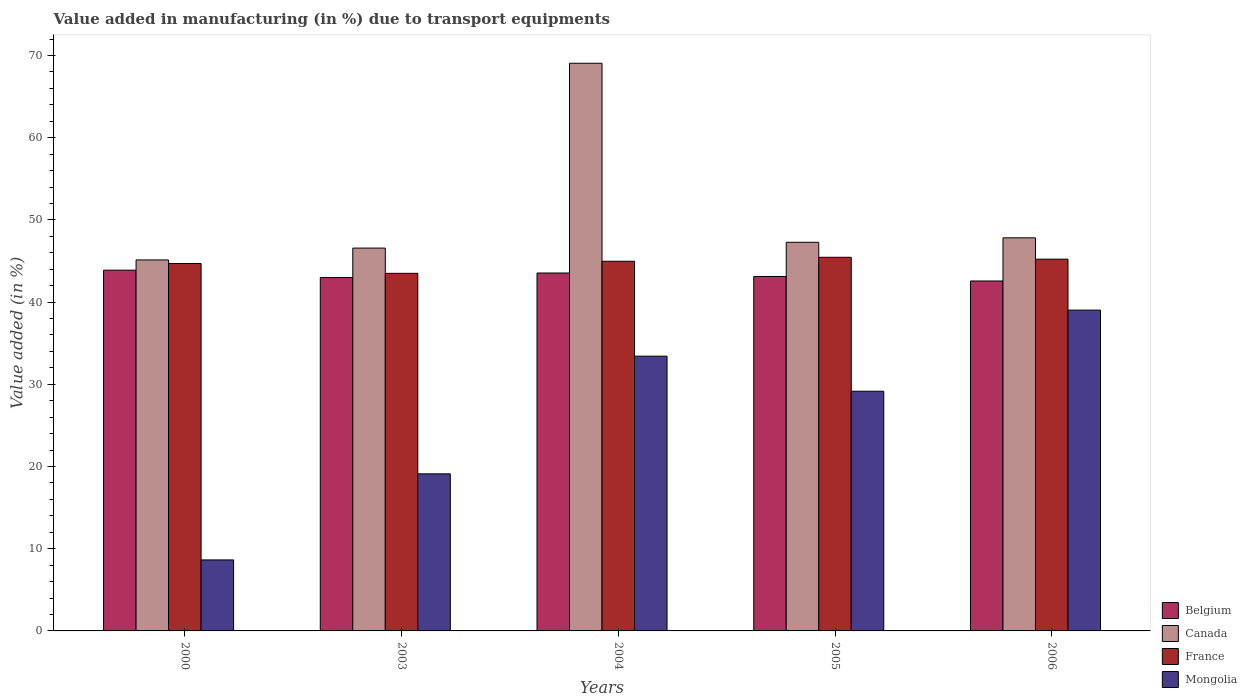How many groups of bars are there?
Your response must be concise. 5. Are the number of bars per tick equal to the number of legend labels?
Keep it short and to the point. Yes. How many bars are there on the 2nd tick from the left?
Give a very brief answer. 4. What is the label of the 3rd group of bars from the left?
Your response must be concise. 2004. What is the percentage of value added in manufacturing due to transport equipments in Belgium in 2006?
Ensure brevity in your answer.  42.57. Across all years, what is the maximum percentage of value added in manufacturing due to transport equipments in France?
Make the answer very short. 45.45. Across all years, what is the minimum percentage of value added in manufacturing due to transport equipments in Canada?
Your answer should be very brief. 45.13. What is the total percentage of value added in manufacturing due to transport equipments in Belgium in the graph?
Your response must be concise. 216.1. What is the difference between the percentage of value added in manufacturing due to transport equipments in Canada in 2000 and that in 2006?
Provide a succinct answer. -2.69. What is the difference between the percentage of value added in manufacturing due to transport equipments in Canada in 2006 and the percentage of value added in manufacturing due to transport equipments in Mongolia in 2004?
Offer a terse response. 14.39. What is the average percentage of value added in manufacturing due to transport equipments in Mongolia per year?
Ensure brevity in your answer.  25.87. In the year 2000, what is the difference between the percentage of value added in manufacturing due to transport equipments in Mongolia and percentage of value added in manufacturing due to transport equipments in France?
Provide a succinct answer. -36.06. In how many years, is the percentage of value added in manufacturing due to transport equipments in France greater than 42 %?
Make the answer very short. 5. What is the ratio of the percentage of value added in manufacturing due to transport equipments in Canada in 2000 to that in 2006?
Give a very brief answer. 0.94. What is the difference between the highest and the second highest percentage of value added in manufacturing due to transport equipments in Mongolia?
Offer a very short reply. 5.6. What is the difference between the highest and the lowest percentage of value added in manufacturing due to transport equipments in Canada?
Ensure brevity in your answer.  23.92. In how many years, is the percentage of value added in manufacturing due to transport equipments in Mongolia greater than the average percentage of value added in manufacturing due to transport equipments in Mongolia taken over all years?
Offer a very short reply. 3. Is it the case that in every year, the sum of the percentage of value added in manufacturing due to transport equipments in Belgium and percentage of value added in manufacturing due to transport equipments in Canada is greater than the sum of percentage of value added in manufacturing due to transport equipments in France and percentage of value added in manufacturing due to transport equipments in Mongolia?
Provide a short and direct response. No. What does the 4th bar from the left in 2000 represents?
Keep it short and to the point. Mongolia. How many bars are there?
Offer a very short reply. 20. How many years are there in the graph?
Your response must be concise. 5. Where does the legend appear in the graph?
Give a very brief answer. Bottom right. How are the legend labels stacked?
Provide a short and direct response. Vertical. What is the title of the graph?
Make the answer very short. Value added in manufacturing (in %) due to transport equipments. Does "San Marino" appear as one of the legend labels in the graph?
Offer a very short reply. No. What is the label or title of the Y-axis?
Your answer should be compact. Value added (in %). What is the Value added (in %) in Belgium in 2000?
Your answer should be very brief. 43.88. What is the Value added (in %) of Canada in 2000?
Provide a succinct answer. 45.13. What is the Value added (in %) in France in 2000?
Your response must be concise. 44.7. What is the Value added (in %) in Mongolia in 2000?
Offer a terse response. 8.64. What is the Value added (in %) of Belgium in 2003?
Ensure brevity in your answer.  42.99. What is the Value added (in %) in Canada in 2003?
Ensure brevity in your answer.  46.57. What is the Value added (in %) of France in 2003?
Keep it short and to the point. 43.5. What is the Value added (in %) in Mongolia in 2003?
Provide a succinct answer. 19.11. What is the Value added (in %) in Belgium in 2004?
Provide a short and direct response. 43.54. What is the Value added (in %) of Canada in 2004?
Keep it short and to the point. 69.05. What is the Value added (in %) in France in 2004?
Your answer should be compact. 44.97. What is the Value added (in %) in Mongolia in 2004?
Offer a very short reply. 33.42. What is the Value added (in %) in Belgium in 2005?
Ensure brevity in your answer.  43.12. What is the Value added (in %) in Canada in 2005?
Your response must be concise. 47.28. What is the Value added (in %) of France in 2005?
Keep it short and to the point. 45.45. What is the Value added (in %) of Mongolia in 2005?
Your response must be concise. 29.16. What is the Value added (in %) of Belgium in 2006?
Provide a succinct answer. 42.57. What is the Value added (in %) of Canada in 2006?
Your response must be concise. 47.82. What is the Value added (in %) in France in 2006?
Make the answer very short. 45.22. What is the Value added (in %) of Mongolia in 2006?
Keep it short and to the point. 39.03. Across all years, what is the maximum Value added (in %) in Belgium?
Make the answer very short. 43.88. Across all years, what is the maximum Value added (in %) in Canada?
Make the answer very short. 69.05. Across all years, what is the maximum Value added (in %) of France?
Provide a succinct answer. 45.45. Across all years, what is the maximum Value added (in %) of Mongolia?
Keep it short and to the point. 39.03. Across all years, what is the minimum Value added (in %) of Belgium?
Provide a succinct answer. 42.57. Across all years, what is the minimum Value added (in %) in Canada?
Provide a short and direct response. 45.13. Across all years, what is the minimum Value added (in %) in France?
Offer a very short reply. 43.5. Across all years, what is the minimum Value added (in %) in Mongolia?
Provide a succinct answer. 8.64. What is the total Value added (in %) in Belgium in the graph?
Offer a very short reply. 216.1. What is the total Value added (in %) in Canada in the graph?
Give a very brief answer. 255.85. What is the total Value added (in %) in France in the graph?
Ensure brevity in your answer.  223.84. What is the total Value added (in %) of Mongolia in the graph?
Provide a succinct answer. 129.35. What is the difference between the Value added (in %) of Belgium in 2000 and that in 2003?
Your answer should be very brief. 0.9. What is the difference between the Value added (in %) of Canada in 2000 and that in 2003?
Make the answer very short. -1.44. What is the difference between the Value added (in %) of France in 2000 and that in 2003?
Your answer should be very brief. 1.2. What is the difference between the Value added (in %) of Mongolia in 2000 and that in 2003?
Provide a succinct answer. -10.47. What is the difference between the Value added (in %) in Belgium in 2000 and that in 2004?
Your answer should be very brief. 0.35. What is the difference between the Value added (in %) of Canada in 2000 and that in 2004?
Your response must be concise. -23.92. What is the difference between the Value added (in %) in France in 2000 and that in 2004?
Make the answer very short. -0.27. What is the difference between the Value added (in %) in Mongolia in 2000 and that in 2004?
Offer a very short reply. -24.79. What is the difference between the Value added (in %) in Belgium in 2000 and that in 2005?
Offer a terse response. 0.77. What is the difference between the Value added (in %) of Canada in 2000 and that in 2005?
Provide a short and direct response. -2.15. What is the difference between the Value added (in %) of France in 2000 and that in 2005?
Your answer should be compact. -0.75. What is the difference between the Value added (in %) of Mongolia in 2000 and that in 2005?
Make the answer very short. -20.52. What is the difference between the Value added (in %) of Belgium in 2000 and that in 2006?
Make the answer very short. 1.32. What is the difference between the Value added (in %) in Canada in 2000 and that in 2006?
Keep it short and to the point. -2.69. What is the difference between the Value added (in %) in France in 2000 and that in 2006?
Give a very brief answer. -0.53. What is the difference between the Value added (in %) in Mongolia in 2000 and that in 2006?
Offer a terse response. -30.39. What is the difference between the Value added (in %) in Belgium in 2003 and that in 2004?
Ensure brevity in your answer.  -0.55. What is the difference between the Value added (in %) in Canada in 2003 and that in 2004?
Make the answer very short. -22.48. What is the difference between the Value added (in %) of France in 2003 and that in 2004?
Keep it short and to the point. -1.47. What is the difference between the Value added (in %) of Mongolia in 2003 and that in 2004?
Your answer should be compact. -14.32. What is the difference between the Value added (in %) of Belgium in 2003 and that in 2005?
Give a very brief answer. -0.13. What is the difference between the Value added (in %) in Canada in 2003 and that in 2005?
Offer a very short reply. -0.71. What is the difference between the Value added (in %) of France in 2003 and that in 2005?
Offer a very short reply. -1.95. What is the difference between the Value added (in %) of Mongolia in 2003 and that in 2005?
Offer a terse response. -10.05. What is the difference between the Value added (in %) in Belgium in 2003 and that in 2006?
Your answer should be compact. 0.42. What is the difference between the Value added (in %) in Canada in 2003 and that in 2006?
Your response must be concise. -1.25. What is the difference between the Value added (in %) in France in 2003 and that in 2006?
Your response must be concise. -1.72. What is the difference between the Value added (in %) in Mongolia in 2003 and that in 2006?
Provide a succinct answer. -19.92. What is the difference between the Value added (in %) in Belgium in 2004 and that in 2005?
Provide a succinct answer. 0.42. What is the difference between the Value added (in %) in Canada in 2004 and that in 2005?
Your answer should be compact. 21.78. What is the difference between the Value added (in %) of France in 2004 and that in 2005?
Make the answer very short. -0.48. What is the difference between the Value added (in %) in Mongolia in 2004 and that in 2005?
Make the answer very short. 4.27. What is the difference between the Value added (in %) of Canada in 2004 and that in 2006?
Make the answer very short. 21.24. What is the difference between the Value added (in %) of France in 2004 and that in 2006?
Your response must be concise. -0.25. What is the difference between the Value added (in %) of Mongolia in 2004 and that in 2006?
Your response must be concise. -5.6. What is the difference between the Value added (in %) of Belgium in 2005 and that in 2006?
Your answer should be compact. 0.55. What is the difference between the Value added (in %) in Canada in 2005 and that in 2006?
Your response must be concise. -0.54. What is the difference between the Value added (in %) of France in 2005 and that in 2006?
Your answer should be very brief. 0.23. What is the difference between the Value added (in %) in Mongolia in 2005 and that in 2006?
Ensure brevity in your answer.  -9.87. What is the difference between the Value added (in %) in Belgium in 2000 and the Value added (in %) in Canada in 2003?
Offer a very short reply. -2.69. What is the difference between the Value added (in %) of Belgium in 2000 and the Value added (in %) of France in 2003?
Your response must be concise. 0.39. What is the difference between the Value added (in %) in Belgium in 2000 and the Value added (in %) in Mongolia in 2003?
Your answer should be compact. 24.78. What is the difference between the Value added (in %) of Canada in 2000 and the Value added (in %) of France in 2003?
Provide a succinct answer. 1.63. What is the difference between the Value added (in %) of Canada in 2000 and the Value added (in %) of Mongolia in 2003?
Provide a short and direct response. 26.02. What is the difference between the Value added (in %) in France in 2000 and the Value added (in %) in Mongolia in 2003?
Your response must be concise. 25.59. What is the difference between the Value added (in %) of Belgium in 2000 and the Value added (in %) of Canada in 2004?
Offer a terse response. -25.17. What is the difference between the Value added (in %) of Belgium in 2000 and the Value added (in %) of France in 2004?
Offer a terse response. -1.08. What is the difference between the Value added (in %) in Belgium in 2000 and the Value added (in %) in Mongolia in 2004?
Offer a terse response. 10.46. What is the difference between the Value added (in %) of Canada in 2000 and the Value added (in %) of France in 2004?
Ensure brevity in your answer.  0.16. What is the difference between the Value added (in %) in Canada in 2000 and the Value added (in %) in Mongolia in 2004?
Your answer should be very brief. 11.71. What is the difference between the Value added (in %) in France in 2000 and the Value added (in %) in Mongolia in 2004?
Your answer should be very brief. 11.27. What is the difference between the Value added (in %) in Belgium in 2000 and the Value added (in %) in Canada in 2005?
Give a very brief answer. -3.39. What is the difference between the Value added (in %) of Belgium in 2000 and the Value added (in %) of France in 2005?
Make the answer very short. -1.57. What is the difference between the Value added (in %) in Belgium in 2000 and the Value added (in %) in Mongolia in 2005?
Provide a short and direct response. 14.73. What is the difference between the Value added (in %) in Canada in 2000 and the Value added (in %) in France in 2005?
Ensure brevity in your answer.  -0.32. What is the difference between the Value added (in %) of Canada in 2000 and the Value added (in %) of Mongolia in 2005?
Your answer should be compact. 15.97. What is the difference between the Value added (in %) of France in 2000 and the Value added (in %) of Mongolia in 2005?
Your response must be concise. 15.54. What is the difference between the Value added (in %) in Belgium in 2000 and the Value added (in %) in Canada in 2006?
Offer a terse response. -3.93. What is the difference between the Value added (in %) in Belgium in 2000 and the Value added (in %) in France in 2006?
Ensure brevity in your answer.  -1.34. What is the difference between the Value added (in %) of Belgium in 2000 and the Value added (in %) of Mongolia in 2006?
Offer a terse response. 4.86. What is the difference between the Value added (in %) in Canada in 2000 and the Value added (in %) in France in 2006?
Offer a terse response. -0.09. What is the difference between the Value added (in %) of Canada in 2000 and the Value added (in %) of Mongolia in 2006?
Make the answer very short. 6.1. What is the difference between the Value added (in %) of France in 2000 and the Value added (in %) of Mongolia in 2006?
Your response must be concise. 5.67. What is the difference between the Value added (in %) in Belgium in 2003 and the Value added (in %) in Canada in 2004?
Keep it short and to the point. -26.07. What is the difference between the Value added (in %) of Belgium in 2003 and the Value added (in %) of France in 2004?
Offer a terse response. -1.98. What is the difference between the Value added (in %) of Belgium in 2003 and the Value added (in %) of Mongolia in 2004?
Your response must be concise. 9.56. What is the difference between the Value added (in %) in Canada in 2003 and the Value added (in %) in France in 2004?
Provide a short and direct response. 1.6. What is the difference between the Value added (in %) of Canada in 2003 and the Value added (in %) of Mongolia in 2004?
Offer a terse response. 13.15. What is the difference between the Value added (in %) of France in 2003 and the Value added (in %) of Mongolia in 2004?
Keep it short and to the point. 10.07. What is the difference between the Value added (in %) in Belgium in 2003 and the Value added (in %) in Canada in 2005?
Your answer should be compact. -4.29. What is the difference between the Value added (in %) of Belgium in 2003 and the Value added (in %) of France in 2005?
Provide a succinct answer. -2.46. What is the difference between the Value added (in %) in Belgium in 2003 and the Value added (in %) in Mongolia in 2005?
Make the answer very short. 13.83. What is the difference between the Value added (in %) in Canada in 2003 and the Value added (in %) in France in 2005?
Give a very brief answer. 1.12. What is the difference between the Value added (in %) in Canada in 2003 and the Value added (in %) in Mongolia in 2005?
Provide a short and direct response. 17.41. What is the difference between the Value added (in %) in France in 2003 and the Value added (in %) in Mongolia in 2005?
Provide a succinct answer. 14.34. What is the difference between the Value added (in %) of Belgium in 2003 and the Value added (in %) of Canada in 2006?
Your response must be concise. -4.83. What is the difference between the Value added (in %) of Belgium in 2003 and the Value added (in %) of France in 2006?
Provide a succinct answer. -2.24. What is the difference between the Value added (in %) in Belgium in 2003 and the Value added (in %) in Mongolia in 2006?
Offer a terse response. 3.96. What is the difference between the Value added (in %) of Canada in 2003 and the Value added (in %) of France in 2006?
Keep it short and to the point. 1.35. What is the difference between the Value added (in %) of Canada in 2003 and the Value added (in %) of Mongolia in 2006?
Your response must be concise. 7.54. What is the difference between the Value added (in %) in France in 2003 and the Value added (in %) in Mongolia in 2006?
Your answer should be very brief. 4.47. What is the difference between the Value added (in %) of Belgium in 2004 and the Value added (in %) of Canada in 2005?
Your response must be concise. -3.74. What is the difference between the Value added (in %) in Belgium in 2004 and the Value added (in %) in France in 2005?
Your response must be concise. -1.91. What is the difference between the Value added (in %) in Belgium in 2004 and the Value added (in %) in Mongolia in 2005?
Provide a succinct answer. 14.38. What is the difference between the Value added (in %) of Canada in 2004 and the Value added (in %) of France in 2005?
Provide a short and direct response. 23.6. What is the difference between the Value added (in %) in Canada in 2004 and the Value added (in %) in Mongolia in 2005?
Your response must be concise. 39.9. What is the difference between the Value added (in %) in France in 2004 and the Value added (in %) in Mongolia in 2005?
Offer a terse response. 15.81. What is the difference between the Value added (in %) in Belgium in 2004 and the Value added (in %) in Canada in 2006?
Offer a very short reply. -4.28. What is the difference between the Value added (in %) of Belgium in 2004 and the Value added (in %) of France in 2006?
Provide a short and direct response. -1.68. What is the difference between the Value added (in %) in Belgium in 2004 and the Value added (in %) in Mongolia in 2006?
Give a very brief answer. 4.51. What is the difference between the Value added (in %) in Canada in 2004 and the Value added (in %) in France in 2006?
Provide a short and direct response. 23.83. What is the difference between the Value added (in %) of Canada in 2004 and the Value added (in %) of Mongolia in 2006?
Provide a short and direct response. 30.03. What is the difference between the Value added (in %) in France in 2004 and the Value added (in %) in Mongolia in 2006?
Provide a short and direct response. 5.94. What is the difference between the Value added (in %) of Belgium in 2005 and the Value added (in %) of Canada in 2006?
Provide a short and direct response. -4.7. What is the difference between the Value added (in %) in Belgium in 2005 and the Value added (in %) in France in 2006?
Keep it short and to the point. -2.11. What is the difference between the Value added (in %) of Belgium in 2005 and the Value added (in %) of Mongolia in 2006?
Provide a short and direct response. 4.09. What is the difference between the Value added (in %) of Canada in 2005 and the Value added (in %) of France in 2006?
Your answer should be compact. 2.05. What is the difference between the Value added (in %) in Canada in 2005 and the Value added (in %) in Mongolia in 2006?
Provide a short and direct response. 8.25. What is the difference between the Value added (in %) in France in 2005 and the Value added (in %) in Mongolia in 2006?
Give a very brief answer. 6.42. What is the average Value added (in %) in Belgium per year?
Provide a succinct answer. 43.22. What is the average Value added (in %) of Canada per year?
Give a very brief answer. 51.17. What is the average Value added (in %) of France per year?
Your response must be concise. 44.77. What is the average Value added (in %) in Mongolia per year?
Provide a succinct answer. 25.87. In the year 2000, what is the difference between the Value added (in %) in Belgium and Value added (in %) in Canada?
Your response must be concise. -1.25. In the year 2000, what is the difference between the Value added (in %) in Belgium and Value added (in %) in France?
Offer a very short reply. -0.81. In the year 2000, what is the difference between the Value added (in %) in Belgium and Value added (in %) in Mongolia?
Offer a terse response. 35.25. In the year 2000, what is the difference between the Value added (in %) of Canada and Value added (in %) of France?
Keep it short and to the point. 0.43. In the year 2000, what is the difference between the Value added (in %) of Canada and Value added (in %) of Mongolia?
Offer a very short reply. 36.49. In the year 2000, what is the difference between the Value added (in %) of France and Value added (in %) of Mongolia?
Offer a very short reply. 36.06. In the year 2003, what is the difference between the Value added (in %) in Belgium and Value added (in %) in Canada?
Give a very brief answer. -3.58. In the year 2003, what is the difference between the Value added (in %) of Belgium and Value added (in %) of France?
Keep it short and to the point. -0.51. In the year 2003, what is the difference between the Value added (in %) of Belgium and Value added (in %) of Mongolia?
Keep it short and to the point. 23.88. In the year 2003, what is the difference between the Value added (in %) of Canada and Value added (in %) of France?
Your answer should be very brief. 3.07. In the year 2003, what is the difference between the Value added (in %) in Canada and Value added (in %) in Mongolia?
Give a very brief answer. 27.46. In the year 2003, what is the difference between the Value added (in %) in France and Value added (in %) in Mongolia?
Make the answer very short. 24.39. In the year 2004, what is the difference between the Value added (in %) of Belgium and Value added (in %) of Canada?
Ensure brevity in your answer.  -25.51. In the year 2004, what is the difference between the Value added (in %) in Belgium and Value added (in %) in France?
Offer a terse response. -1.43. In the year 2004, what is the difference between the Value added (in %) of Belgium and Value added (in %) of Mongolia?
Give a very brief answer. 10.12. In the year 2004, what is the difference between the Value added (in %) of Canada and Value added (in %) of France?
Your answer should be compact. 24.09. In the year 2004, what is the difference between the Value added (in %) of Canada and Value added (in %) of Mongolia?
Give a very brief answer. 35.63. In the year 2004, what is the difference between the Value added (in %) in France and Value added (in %) in Mongolia?
Your response must be concise. 11.54. In the year 2005, what is the difference between the Value added (in %) in Belgium and Value added (in %) in Canada?
Provide a succinct answer. -4.16. In the year 2005, what is the difference between the Value added (in %) in Belgium and Value added (in %) in France?
Provide a succinct answer. -2.33. In the year 2005, what is the difference between the Value added (in %) of Belgium and Value added (in %) of Mongolia?
Provide a short and direct response. 13.96. In the year 2005, what is the difference between the Value added (in %) of Canada and Value added (in %) of France?
Provide a short and direct response. 1.83. In the year 2005, what is the difference between the Value added (in %) in Canada and Value added (in %) in Mongolia?
Ensure brevity in your answer.  18.12. In the year 2005, what is the difference between the Value added (in %) of France and Value added (in %) of Mongolia?
Keep it short and to the point. 16.29. In the year 2006, what is the difference between the Value added (in %) of Belgium and Value added (in %) of Canada?
Your response must be concise. -5.25. In the year 2006, what is the difference between the Value added (in %) of Belgium and Value added (in %) of France?
Your response must be concise. -2.66. In the year 2006, what is the difference between the Value added (in %) of Belgium and Value added (in %) of Mongolia?
Your answer should be very brief. 3.54. In the year 2006, what is the difference between the Value added (in %) in Canada and Value added (in %) in France?
Offer a very short reply. 2.59. In the year 2006, what is the difference between the Value added (in %) of Canada and Value added (in %) of Mongolia?
Provide a short and direct response. 8.79. In the year 2006, what is the difference between the Value added (in %) of France and Value added (in %) of Mongolia?
Your response must be concise. 6.2. What is the ratio of the Value added (in %) in Belgium in 2000 to that in 2003?
Your answer should be very brief. 1.02. What is the ratio of the Value added (in %) in Canada in 2000 to that in 2003?
Provide a short and direct response. 0.97. What is the ratio of the Value added (in %) in France in 2000 to that in 2003?
Ensure brevity in your answer.  1.03. What is the ratio of the Value added (in %) of Mongolia in 2000 to that in 2003?
Your response must be concise. 0.45. What is the ratio of the Value added (in %) of Belgium in 2000 to that in 2004?
Offer a terse response. 1.01. What is the ratio of the Value added (in %) in Canada in 2000 to that in 2004?
Offer a terse response. 0.65. What is the ratio of the Value added (in %) in France in 2000 to that in 2004?
Offer a terse response. 0.99. What is the ratio of the Value added (in %) in Mongolia in 2000 to that in 2004?
Make the answer very short. 0.26. What is the ratio of the Value added (in %) in Belgium in 2000 to that in 2005?
Give a very brief answer. 1.02. What is the ratio of the Value added (in %) in Canada in 2000 to that in 2005?
Your answer should be compact. 0.95. What is the ratio of the Value added (in %) in France in 2000 to that in 2005?
Offer a terse response. 0.98. What is the ratio of the Value added (in %) of Mongolia in 2000 to that in 2005?
Your response must be concise. 0.3. What is the ratio of the Value added (in %) of Belgium in 2000 to that in 2006?
Your response must be concise. 1.03. What is the ratio of the Value added (in %) of Canada in 2000 to that in 2006?
Ensure brevity in your answer.  0.94. What is the ratio of the Value added (in %) in France in 2000 to that in 2006?
Give a very brief answer. 0.99. What is the ratio of the Value added (in %) of Mongolia in 2000 to that in 2006?
Ensure brevity in your answer.  0.22. What is the ratio of the Value added (in %) of Belgium in 2003 to that in 2004?
Keep it short and to the point. 0.99. What is the ratio of the Value added (in %) of Canada in 2003 to that in 2004?
Make the answer very short. 0.67. What is the ratio of the Value added (in %) in France in 2003 to that in 2004?
Your response must be concise. 0.97. What is the ratio of the Value added (in %) in Mongolia in 2003 to that in 2004?
Keep it short and to the point. 0.57. What is the ratio of the Value added (in %) in Belgium in 2003 to that in 2005?
Keep it short and to the point. 1. What is the ratio of the Value added (in %) of Canada in 2003 to that in 2005?
Your response must be concise. 0.99. What is the ratio of the Value added (in %) of France in 2003 to that in 2005?
Make the answer very short. 0.96. What is the ratio of the Value added (in %) in Mongolia in 2003 to that in 2005?
Make the answer very short. 0.66. What is the ratio of the Value added (in %) in Belgium in 2003 to that in 2006?
Keep it short and to the point. 1.01. What is the ratio of the Value added (in %) of Canada in 2003 to that in 2006?
Provide a succinct answer. 0.97. What is the ratio of the Value added (in %) of France in 2003 to that in 2006?
Offer a very short reply. 0.96. What is the ratio of the Value added (in %) of Mongolia in 2003 to that in 2006?
Ensure brevity in your answer.  0.49. What is the ratio of the Value added (in %) of Belgium in 2004 to that in 2005?
Offer a very short reply. 1.01. What is the ratio of the Value added (in %) in Canada in 2004 to that in 2005?
Keep it short and to the point. 1.46. What is the ratio of the Value added (in %) of France in 2004 to that in 2005?
Your answer should be compact. 0.99. What is the ratio of the Value added (in %) of Mongolia in 2004 to that in 2005?
Offer a terse response. 1.15. What is the ratio of the Value added (in %) of Belgium in 2004 to that in 2006?
Provide a succinct answer. 1.02. What is the ratio of the Value added (in %) in Canada in 2004 to that in 2006?
Offer a terse response. 1.44. What is the ratio of the Value added (in %) of France in 2004 to that in 2006?
Offer a terse response. 0.99. What is the ratio of the Value added (in %) in Mongolia in 2004 to that in 2006?
Ensure brevity in your answer.  0.86. What is the ratio of the Value added (in %) in Belgium in 2005 to that in 2006?
Offer a very short reply. 1.01. What is the ratio of the Value added (in %) of Canada in 2005 to that in 2006?
Keep it short and to the point. 0.99. What is the ratio of the Value added (in %) of France in 2005 to that in 2006?
Make the answer very short. 1. What is the ratio of the Value added (in %) of Mongolia in 2005 to that in 2006?
Offer a very short reply. 0.75. What is the difference between the highest and the second highest Value added (in %) of Belgium?
Offer a terse response. 0.35. What is the difference between the highest and the second highest Value added (in %) in Canada?
Offer a terse response. 21.24. What is the difference between the highest and the second highest Value added (in %) of France?
Ensure brevity in your answer.  0.23. What is the difference between the highest and the second highest Value added (in %) of Mongolia?
Give a very brief answer. 5.6. What is the difference between the highest and the lowest Value added (in %) in Belgium?
Provide a succinct answer. 1.32. What is the difference between the highest and the lowest Value added (in %) of Canada?
Give a very brief answer. 23.92. What is the difference between the highest and the lowest Value added (in %) in France?
Ensure brevity in your answer.  1.95. What is the difference between the highest and the lowest Value added (in %) in Mongolia?
Offer a very short reply. 30.39. 